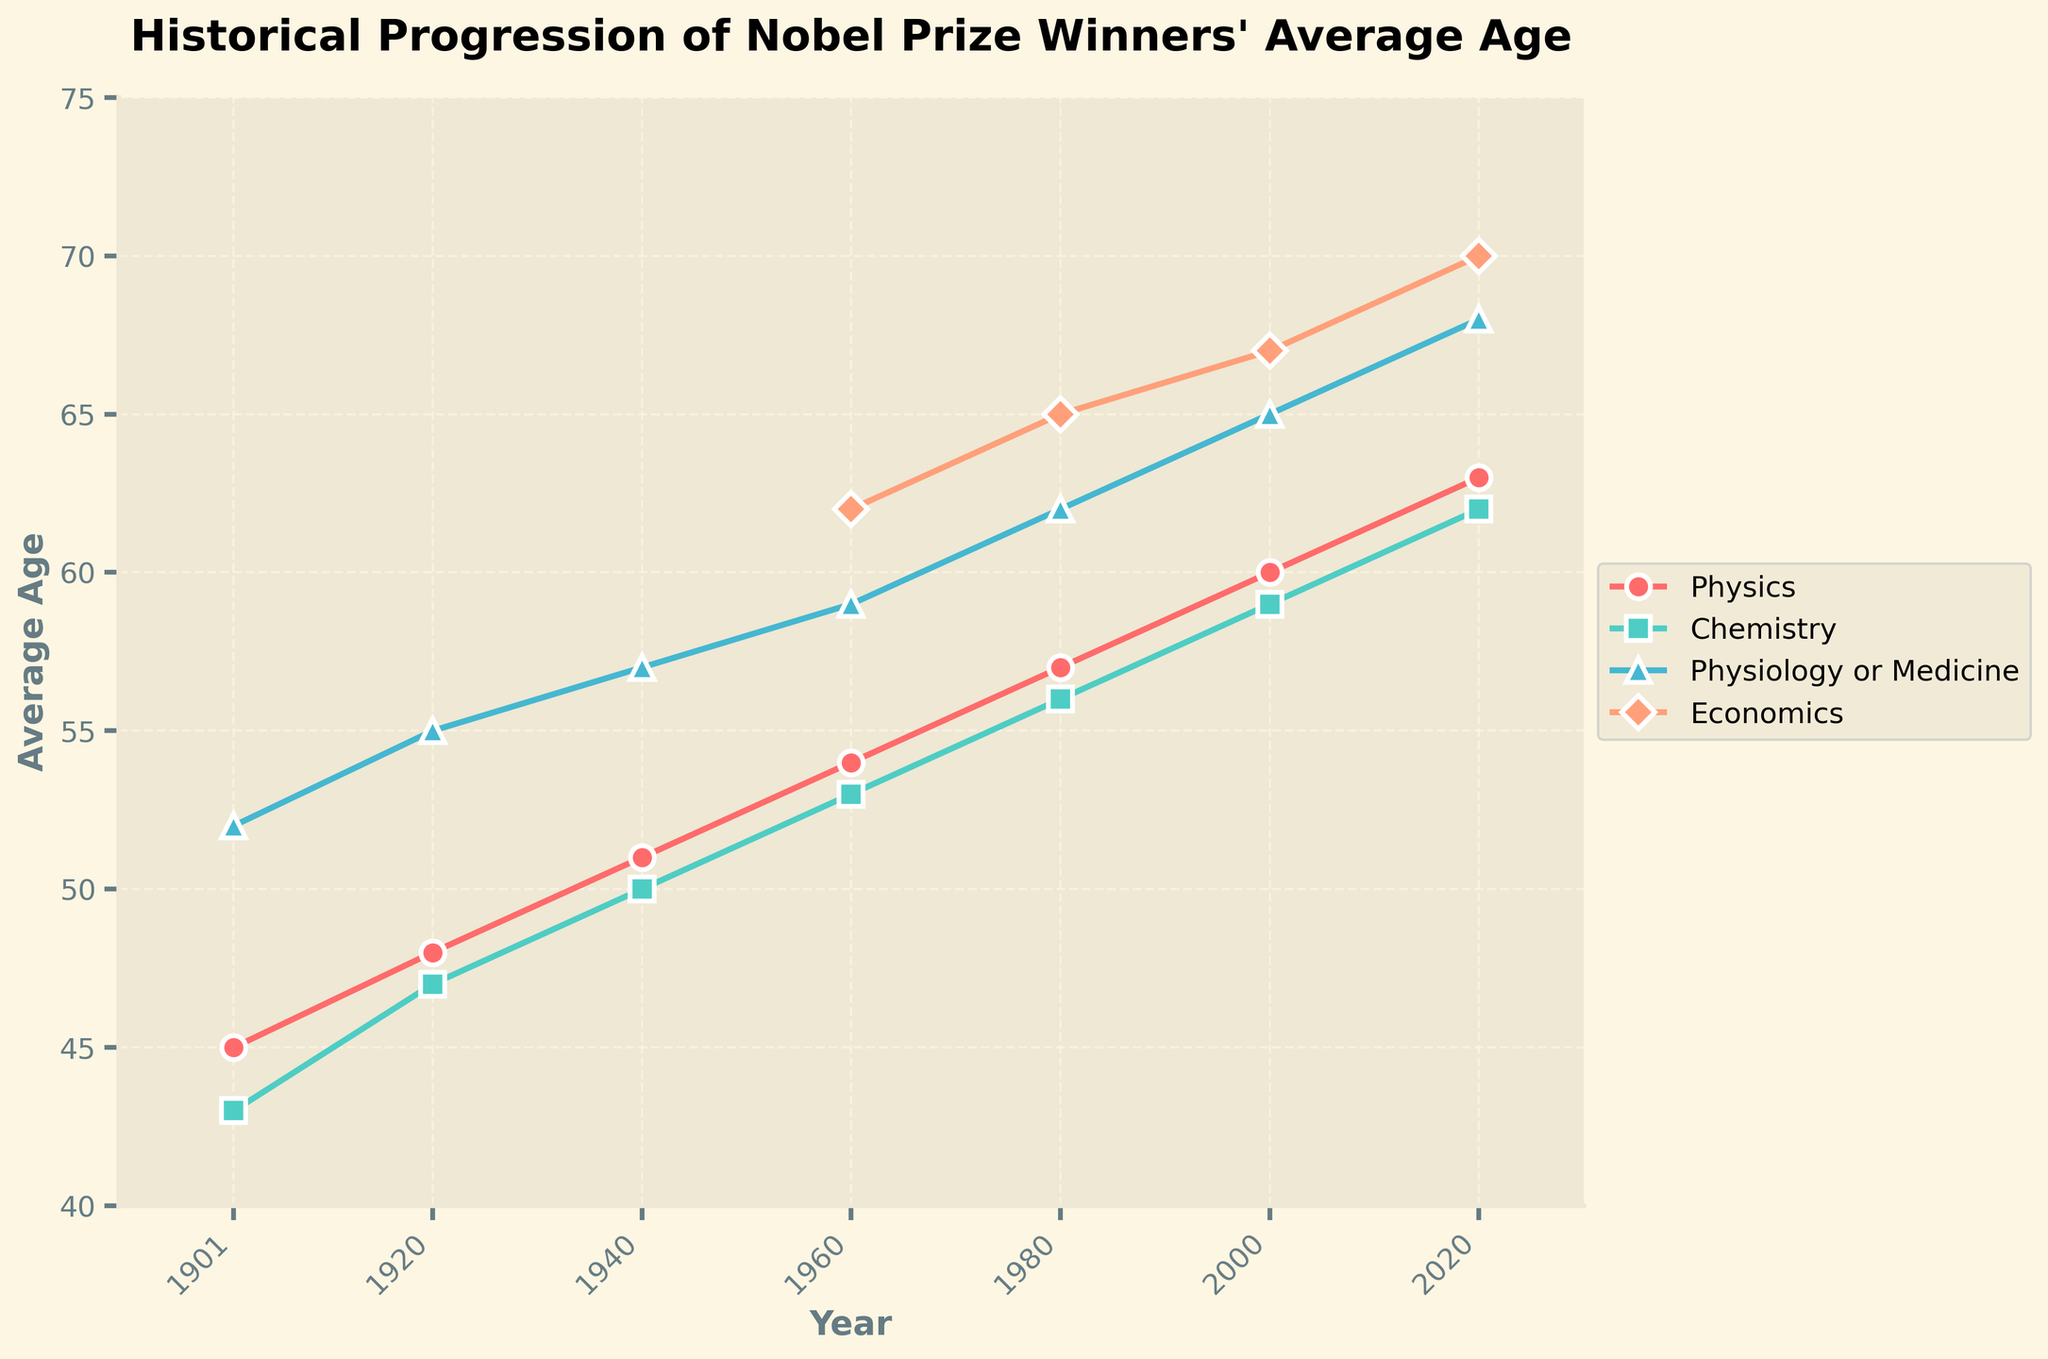What's the general trend in the average age of Nobel Prize winners in Physiology or Medicine from 1901 to 2020? Over the years, the average age of Nobel Prize winners in Physiology or Medicine has shown a steady increase. Initially, in 1901, the average age was 52 years, and by 2020, it had climbed to 68 years.
Answer: Increase Which field had the highest average age of Nobel Prize winners in 2020? In 2020, the plotted data depicts that the Nobel Prize field of Economics had the highest average age of winners at 70 years.
Answer: Economics How does the average age of Chemistry Nobel Prize winners in 1980 compare to that of Physics winners in the same year? In 1980, the average age of Chemistry Nobel Prize winners is 56 years, while that of Physics winners is 57 years. Chemistry winners were slightly younger.
Answer: Chemistry winners were younger What is the difference in the average age of Nobel Prize winners in Physics between 1901 and 2020? The average age of Physics Nobel Prize winners in 1901 was 45 years, and in 2020 it was 63 years. The difference in the average age over this period is 63 - 45 = 18 years.
Answer: 18 years Which field saw the highest increase in the average age of Nobel Prize winners from 1960 to 2020? Between 1960 and 2020, Physiology or Medicine saw the highest increase in average age from 59 years to 68 years. This is an increase of 68 - 59 = 9 years. The other fields did not have a greater increase within this period.
Answer: Physiology or Medicine At what year did the Economics field start showing data in the chart, and what was the average age of winners at that time? The chart begins showing data for the Economics field in 1960, and the average age of the winners at that time was 62 years.
Answer: 1960, 62 years What is the average age of Nobel Prize winners across all fields in 1960? The average age across the four fields (Physics, Chemistry, Physiology or Medicine, and Economics) in 1960 sums to: 54 (Physics) + 53 (Chemistry) + 59 (Physiology or Medicine) + 62 (Economics) = 228. The average is then 228 / 4 = 57 years.
Answer: 57 years Compare the pace of increase in average age between Chemistry and Physics fields from 1901 to 2020. Which field shows a more rapid increase? From 1901 to 2020, the average age for Chemistry winners increased from 43 to 62 years, which is an increase of 19 years. For Physics, the increase was from 45 to 63 years, which is an increase of 18 years. Chemistry shows a more rapid increase.
Answer: Chemistry Which had a smaller average age in 1920, Chemistry or Physiology or Medicine? In 1920, Chemistry had an average age of 47 years, whereas Physiology or Medicine had an average age of 55 years. Thus, winners in Chemistry were younger.
Answer: Chemistry What is the median value of the average age of Economics Nobel Prize winners as shown in the chart? The average ages provided for Economics are 62 (1960), 65 (1980), 67 (2000), and 70 (2020). Arranging these values, the middle values are 65 and 67. The median is the average of these two values: (65 + 67) / 2 = 66.
Answer: 66 